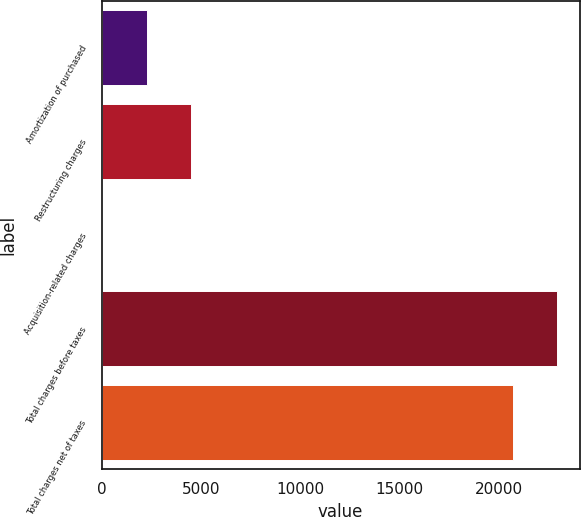<chart> <loc_0><loc_0><loc_500><loc_500><bar_chart><fcel>Amortization of purchased<fcel>Restructuring charges<fcel>Acquisition-related charges<fcel>Total charges before taxes<fcel>Total charges net of taxes<nl><fcel>2260.7<fcel>4476.4<fcel>45<fcel>22900.7<fcel>20685<nl></chart> 